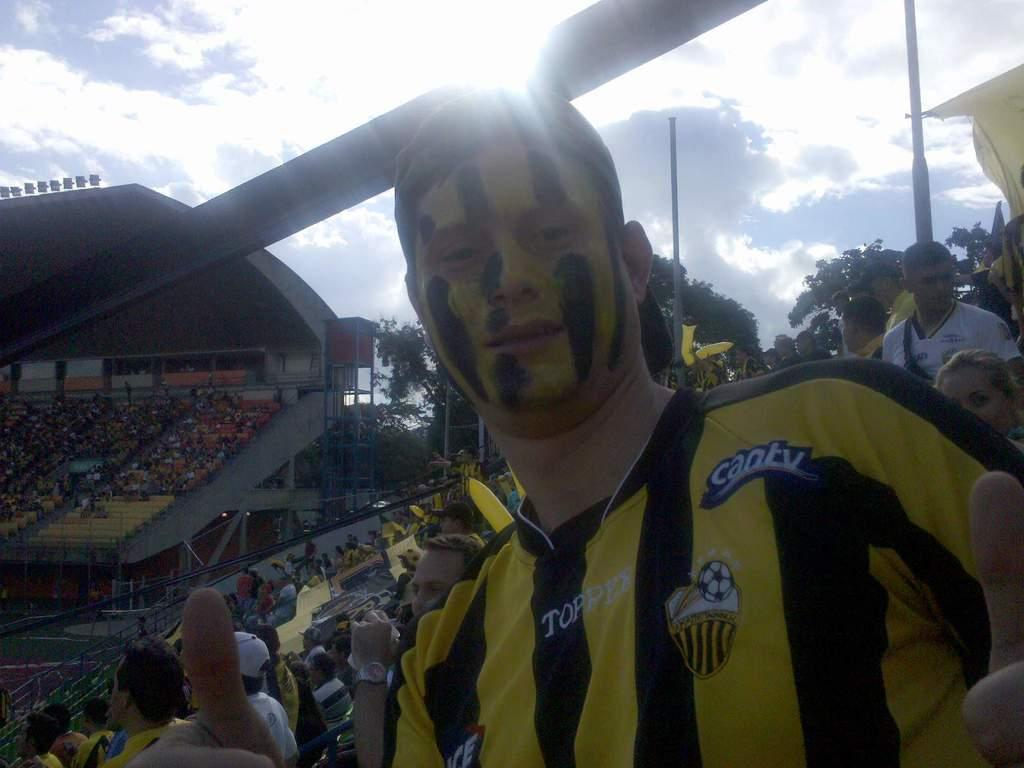<image>
Describe the image concisely. A soccer fan wears a jersey which says Topp on the front of it. 